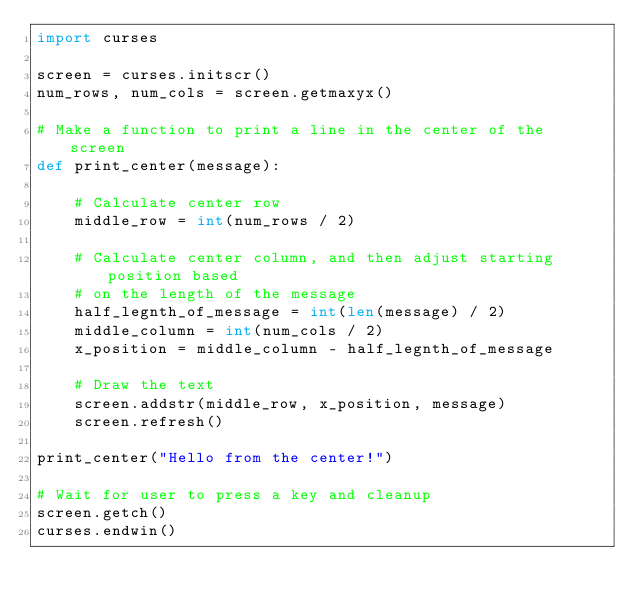Convert code to text. <code><loc_0><loc_0><loc_500><loc_500><_Python_>import curses

screen = curses.initscr()
num_rows, num_cols = screen.getmaxyx()

# Make a function to print a line in the center of the screen
def print_center(message):
    
    # Calculate center row
    middle_row = int(num_rows / 2)
    
    # Calculate center column, and then adjust starting position based
    # on the length of the message
    half_legnth_of_message = int(len(message) / 2)
    middle_column = int(num_cols / 2)
    x_position = middle_column - half_legnth_of_message
    
    # Draw the text
    screen.addstr(middle_row, x_position, message)
    screen.refresh()
    
print_center("Hello from the center!")

# Wait for user to press a key and cleanup
screen.getch()
curses.endwin()</code> 